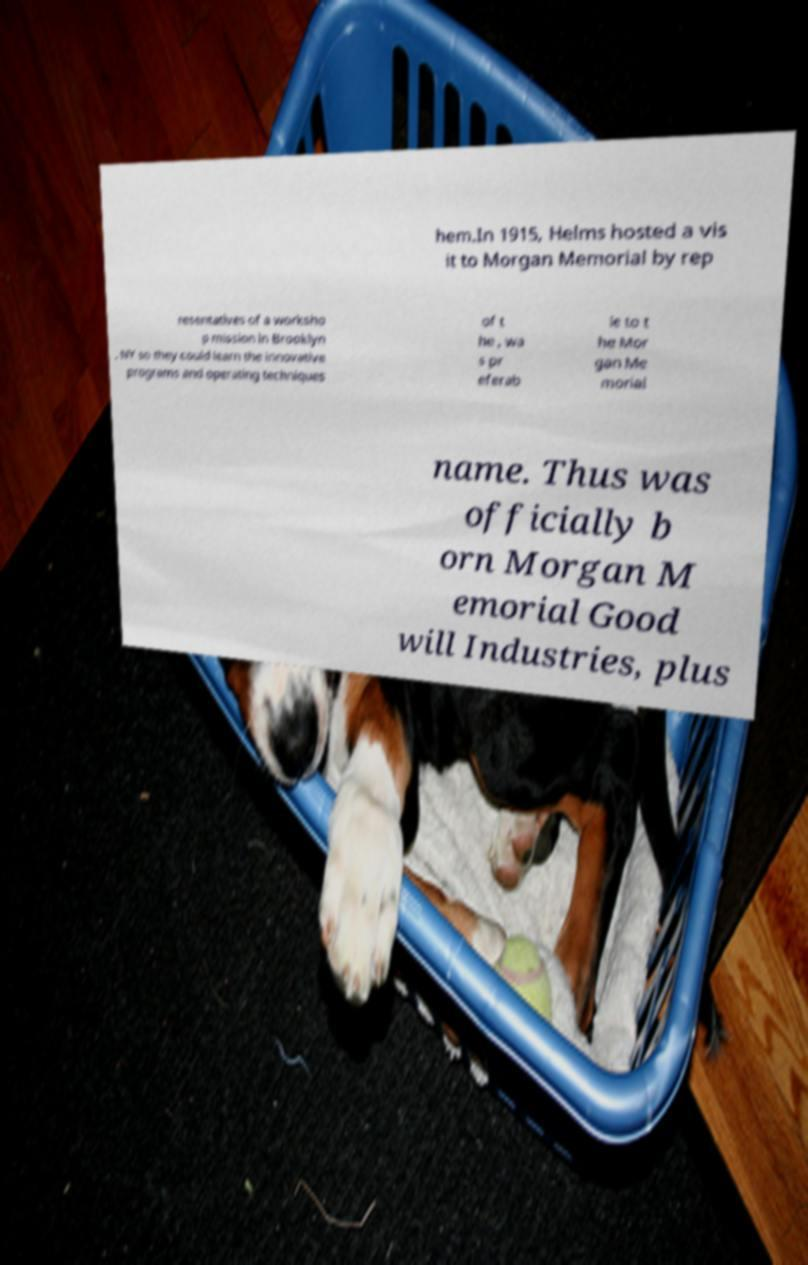Can you read and provide the text displayed in the image?This photo seems to have some interesting text. Can you extract and type it out for me? hem.In 1915, Helms hosted a vis it to Morgan Memorial by rep resentatives of a worksho p mission in Brooklyn , NY so they could learn the innovative programs and operating techniques of t he , wa s pr eferab le to t he Mor gan Me morial name. Thus was officially b orn Morgan M emorial Good will Industries, plus 